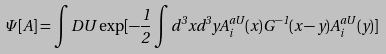Convert formula to latex. <formula><loc_0><loc_0><loc_500><loc_500>\Psi [ A ] = \int D U \exp [ - \frac { 1 } { 2 } \int d ^ { 3 } x d ^ { 3 } y A _ { i } ^ { a U } ( x ) G ^ { - 1 } ( x - y ) A _ { i } ^ { a U } ( y ) ]</formula> 